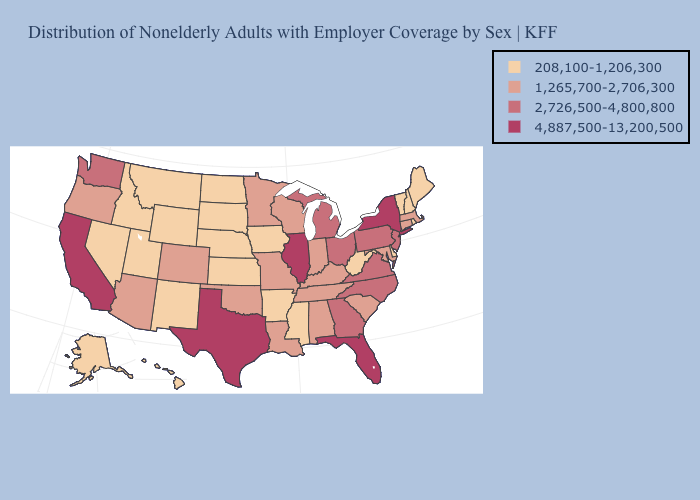Which states have the lowest value in the USA?
Write a very short answer. Alaska, Arkansas, Delaware, Hawaii, Idaho, Iowa, Kansas, Maine, Mississippi, Montana, Nebraska, Nevada, New Hampshire, New Mexico, North Dakota, Rhode Island, South Dakota, Utah, Vermont, West Virginia, Wyoming. What is the value of Wyoming?
Quick response, please. 208,100-1,206,300. What is the highest value in the USA?
Give a very brief answer. 4,887,500-13,200,500. Does the first symbol in the legend represent the smallest category?
Short answer required. Yes. Among the states that border Virginia , does West Virginia have the highest value?
Write a very short answer. No. Does the first symbol in the legend represent the smallest category?
Answer briefly. Yes. Does South Dakota have the lowest value in the MidWest?
Give a very brief answer. Yes. What is the lowest value in states that border Oregon?
Answer briefly. 208,100-1,206,300. Which states have the lowest value in the USA?
Concise answer only. Alaska, Arkansas, Delaware, Hawaii, Idaho, Iowa, Kansas, Maine, Mississippi, Montana, Nebraska, Nevada, New Hampshire, New Mexico, North Dakota, Rhode Island, South Dakota, Utah, Vermont, West Virginia, Wyoming. What is the value of New York?
Short answer required. 4,887,500-13,200,500. What is the value of North Carolina?
Be succinct. 2,726,500-4,800,800. Does Delaware have the same value as Hawaii?
Concise answer only. Yes. What is the lowest value in the USA?
Write a very short answer. 208,100-1,206,300. Which states have the lowest value in the USA?
Quick response, please. Alaska, Arkansas, Delaware, Hawaii, Idaho, Iowa, Kansas, Maine, Mississippi, Montana, Nebraska, Nevada, New Hampshire, New Mexico, North Dakota, Rhode Island, South Dakota, Utah, Vermont, West Virginia, Wyoming. Does Wisconsin have a higher value than Missouri?
Short answer required. No. 